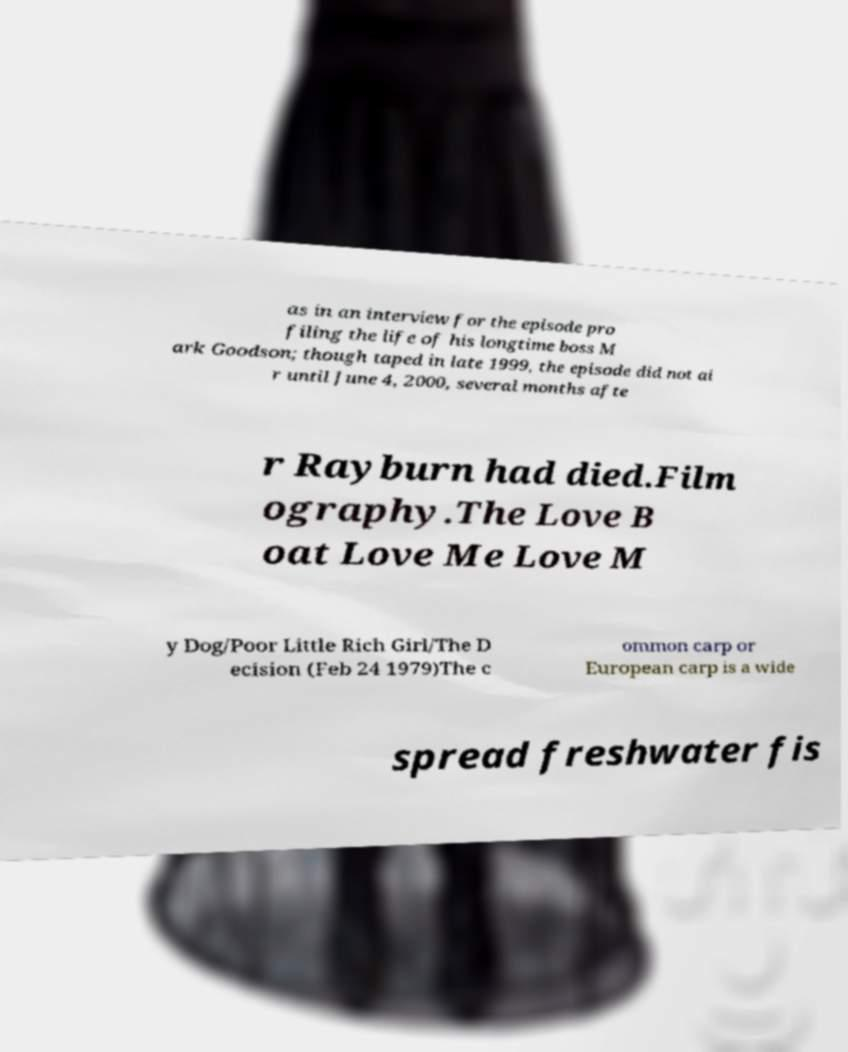What messages or text are displayed in this image? I need them in a readable, typed format. as in an interview for the episode pro filing the life of his longtime boss M ark Goodson; though taped in late 1999, the episode did not ai r until June 4, 2000, several months afte r Rayburn had died.Film ography.The Love B oat Love Me Love M y Dog/Poor Little Rich Girl/The D ecision (Feb 24 1979)The c ommon carp or European carp is a wide spread freshwater fis 